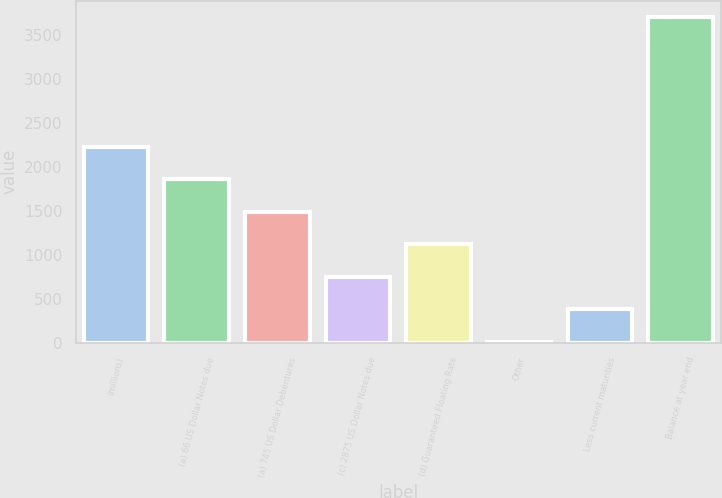<chart> <loc_0><loc_0><loc_500><loc_500><bar_chart><fcel>(millions)<fcel>(a) 66 US Dollar Notes due<fcel>(a) 745 US Dollar Debentures<fcel>(c) 2875 US Dollar Notes due<fcel>(d) Guaranteed Floating Rate<fcel>Other<fcel>Less current maturities<fcel>Balance at year end<nl><fcel>2226.88<fcel>1857.95<fcel>1489.02<fcel>751.16<fcel>1120.09<fcel>13.3<fcel>382.23<fcel>3702.6<nl></chart> 